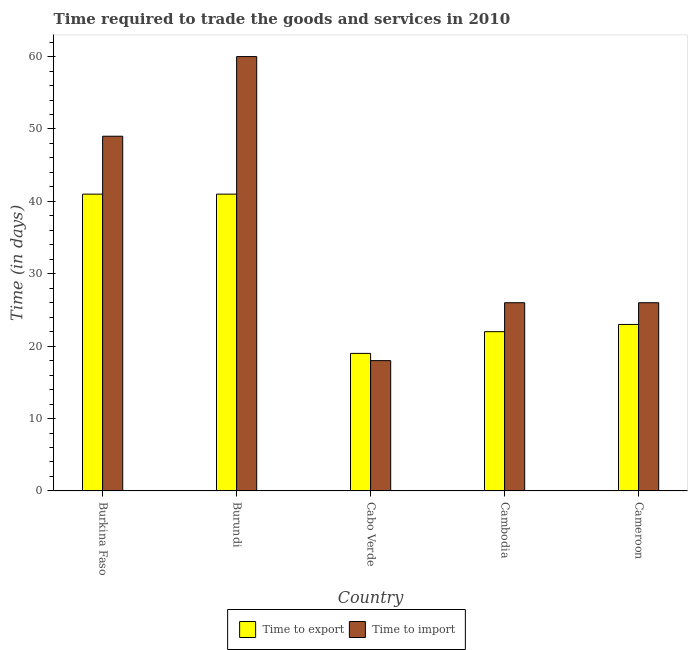How many different coloured bars are there?
Your answer should be compact. 2. Are the number of bars per tick equal to the number of legend labels?
Make the answer very short. Yes. How many bars are there on the 2nd tick from the left?
Keep it short and to the point. 2. How many bars are there on the 2nd tick from the right?
Your answer should be compact. 2. What is the label of the 2nd group of bars from the left?
Provide a succinct answer. Burundi. In which country was the time to export maximum?
Ensure brevity in your answer.  Burkina Faso. In which country was the time to export minimum?
Ensure brevity in your answer.  Cabo Verde. What is the total time to export in the graph?
Your answer should be compact. 146. What is the average time to export per country?
Offer a terse response. 29.2. What is the ratio of the time to export in Burkina Faso to that in Cambodia?
Your response must be concise. 1.86. In how many countries, is the time to import greater than the average time to import taken over all countries?
Offer a terse response. 2. What does the 1st bar from the left in Burundi represents?
Keep it short and to the point. Time to export. What does the 1st bar from the right in Cameroon represents?
Ensure brevity in your answer.  Time to import. Does the graph contain grids?
Ensure brevity in your answer.  No. Where does the legend appear in the graph?
Keep it short and to the point. Bottom center. What is the title of the graph?
Give a very brief answer. Time required to trade the goods and services in 2010. Does "Age 65(male)" appear as one of the legend labels in the graph?
Offer a terse response. No. What is the label or title of the Y-axis?
Keep it short and to the point. Time (in days). What is the Time (in days) in Time to export in Burkina Faso?
Ensure brevity in your answer.  41. What is the Time (in days) in Time to import in Cabo Verde?
Provide a succinct answer. 18. What is the Time (in days) of Time to export in Cameroon?
Make the answer very short. 23. What is the Time (in days) in Time to import in Cameroon?
Offer a very short reply. 26. What is the total Time (in days) of Time to export in the graph?
Your answer should be very brief. 146. What is the total Time (in days) in Time to import in the graph?
Make the answer very short. 179. What is the difference between the Time (in days) of Time to export in Burkina Faso and that in Burundi?
Offer a terse response. 0. What is the difference between the Time (in days) in Time to import in Burkina Faso and that in Burundi?
Your answer should be very brief. -11. What is the difference between the Time (in days) of Time to export in Burkina Faso and that in Cabo Verde?
Keep it short and to the point. 22. What is the difference between the Time (in days) of Time to import in Burkina Faso and that in Cabo Verde?
Your response must be concise. 31. What is the difference between the Time (in days) of Time to import in Burkina Faso and that in Cambodia?
Keep it short and to the point. 23. What is the difference between the Time (in days) of Time to import in Burundi and that in Cabo Verde?
Your answer should be very brief. 42. What is the difference between the Time (in days) in Time to export in Burundi and that in Cambodia?
Keep it short and to the point. 19. What is the difference between the Time (in days) in Time to import in Burundi and that in Cambodia?
Offer a terse response. 34. What is the difference between the Time (in days) of Time to import in Cabo Verde and that in Cameroon?
Provide a short and direct response. -8. What is the difference between the Time (in days) in Time to export in Burkina Faso and the Time (in days) in Time to import in Burundi?
Your answer should be compact. -19. What is the difference between the Time (in days) in Time to export in Burkina Faso and the Time (in days) in Time to import in Cambodia?
Offer a terse response. 15. What is the difference between the Time (in days) of Time to export in Burkina Faso and the Time (in days) of Time to import in Cameroon?
Keep it short and to the point. 15. What is the difference between the Time (in days) of Time to export in Burundi and the Time (in days) of Time to import in Cambodia?
Your response must be concise. 15. What is the difference between the Time (in days) of Time to export in Cabo Verde and the Time (in days) of Time to import in Cambodia?
Your answer should be compact. -7. What is the difference between the Time (in days) in Time to export in Cabo Verde and the Time (in days) in Time to import in Cameroon?
Give a very brief answer. -7. What is the average Time (in days) of Time to export per country?
Your answer should be very brief. 29.2. What is the average Time (in days) of Time to import per country?
Your answer should be compact. 35.8. What is the difference between the Time (in days) in Time to export and Time (in days) in Time to import in Burundi?
Give a very brief answer. -19. What is the difference between the Time (in days) of Time to export and Time (in days) of Time to import in Cabo Verde?
Provide a succinct answer. 1. What is the difference between the Time (in days) in Time to export and Time (in days) in Time to import in Cambodia?
Offer a very short reply. -4. What is the difference between the Time (in days) in Time to export and Time (in days) in Time to import in Cameroon?
Your response must be concise. -3. What is the ratio of the Time (in days) of Time to import in Burkina Faso to that in Burundi?
Give a very brief answer. 0.82. What is the ratio of the Time (in days) of Time to export in Burkina Faso to that in Cabo Verde?
Your answer should be very brief. 2.16. What is the ratio of the Time (in days) in Time to import in Burkina Faso to that in Cabo Verde?
Keep it short and to the point. 2.72. What is the ratio of the Time (in days) of Time to export in Burkina Faso to that in Cambodia?
Offer a very short reply. 1.86. What is the ratio of the Time (in days) in Time to import in Burkina Faso to that in Cambodia?
Your answer should be very brief. 1.88. What is the ratio of the Time (in days) of Time to export in Burkina Faso to that in Cameroon?
Your response must be concise. 1.78. What is the ratio of the Time (in days) of Time to import in Burkina Faso to that in Cameroon?
Ensure brevity in your answer.  1.88. What is the ratio of the Time (in days) of Time to export in Burundi to that in Cabo Verde?
Provide a succinct answer. 2.16. What is the ratio of the Time (in days) in Time to export in Burundi to that in Cambodia?
Give a very brief answer. 1.86. What is the ratio of the Time (in days) in Time to import in Burundi to that in Cambodia?
Provide a succinct answer. 2.31. What is the ratio of the Time (in days) of Time to export in Burundi to that in Cameroon?
Offer a terse response. 1.78. What is the ratio of the Time (in days) in Time to import in Burundi to that in Cameroon?
Ensure brevity in your answer.  2.31. What is the ratio of the Time (in days) of Time to export in Cabo Verde to that in Cambodia?
Give a very brief answer. 0.86. What is the ratio of the Time (in days) in Time to import in Cabo Verde to that in Cambodia?
Offer a terse response. 0.69. What is the ratio of the Time (in days) in Time to export in Cabo Verde to that in Cameroon?
Your answer should be compact. 0.83. What is the ratio of the Time (in days) in Time to import in Cabo Verde to that in Cameroon?
Your response must be concise. 0.69. What is the ratio of the Time (in days) of Time to export in Cambodia to that in Cameroon?
Your answer should be very brief. 0.96. What is the ratio of the Time (in days) of Time to import in Cambodia to that in Cameroon?
Provide a short and direct response. 1. What is the difference between the highest and the lowest Time (in days) of Time to import?
Offer a terse response. 42. 